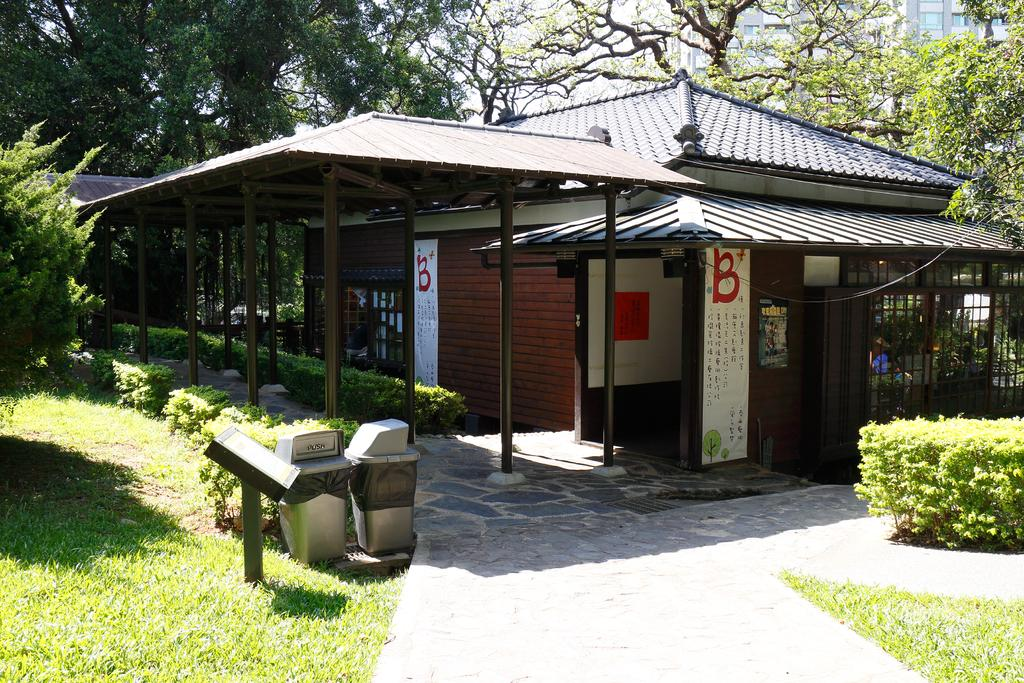What type of structures can be seen in the image? There are buildings in the image. What feature is common among many of the structures? There are windows visible in the image. What type of small storage building is present in the image? There is a shed in the image. What are the tall, thin objects in the image? There are poles in the image. What objects are used for waste disposal in the image? Dustbins are present in the image. What type of vegetation is visible in the image? There are trees in the image. What is attached to one of the poles in the image? A board is attached to a pole in the image. What type of bone can be seen hanging from the tree in the image? There is no bone present in the image; it features buildings, windows, a shed, poles, dustbins, trees, and a board attached to a pole. What type of fruit can be seen growing on the board attached to the pole in the image? There are no fruits present on the board attached to the pole in the image. 